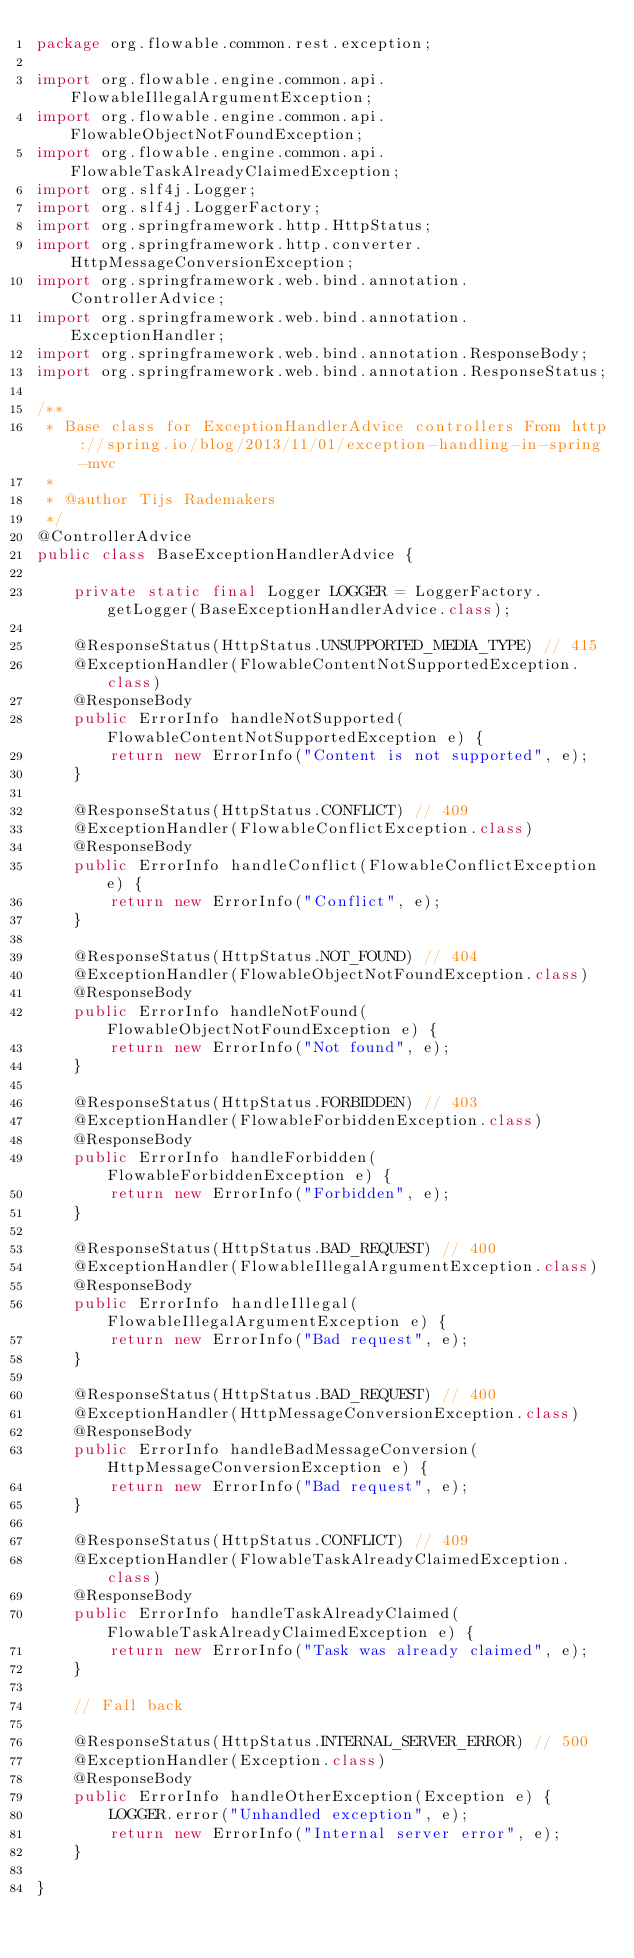<code> <loc_0><loc_0><loc_500><loc_500><_Java_>package org.flowable.common.rest.exception;

import org.flowable.engine.common.api.FlowableIllegalArgumentException;
import org.flowable.engine.common.api.FlowableObjectNotFoundException;
import org.flowable.engine.common.api.FlowableTaskAlreadyClaimedException;
import org.slf4j.Logger;
import org.slf4j.LoggerFactory;
import org.springframework.http.HttpStatus;
import org.springframework.http.converter.HttpMessageConversionException;
import org.springframework.web.bind.annotation.ControllerAdvice;
import org.springframework.web.bind.annotation.ExceptionHandler;
import org.springframework.web.bind.annotation.ResponseBody;
import org.springframework.web.bind.annotation.ResponseStatus;

/**
 * Base class for ExceptionHandlerAdvice controllers From http://spring.io/blog/2013/11/01/exception-handling-in-spring-mvc
 * 
 * @author Tijs Rademakers
 */
@ControllerAdvice
public class BaseExceptionHandlerAdvice {

    private static final Logger LOGGER = LoggerFactory.getLogger(BaseExceptionHandlerAdvice.class);

    @ResponseStatus(HttpStatus.UNSUPPORTED_MEDIA_TYPE) // 415
    @ExceptionHandler(FlowableContentNotSupportedException.class)
    @ResponseBody
    public ErrorInfo handleNotSupported(FlowableContentNotSupportedException e) {
        return new ErrorInfo("Content is not supported", e);
    }

    @ResponseStatus(HttpStatus.CONFLICT) // 409
    @ExceptionHandler(FlowableConflictException.class)
    @ResponseBody
    public ErrorInfo handleConflict(FlowableConflictException e) {
        return new ErrorInfo("Conflict", e);
    }

    @ResponseStatus(HttpStatus.NOT_FOUND) // 404
    @ExceptionHandler(FlowableObjectNotFoundException.class)
    @ResponseBody
    public ErrorInfo handleNotFound(FlowableObjectNotFoundException e) {
        return new ErrorInfo("Not found", e);
    }

    @ResponseStatus(HttpStatus.FORBIDDEN) // 403
    @ExceptionHandler(FlowableForbiddenException.class)
    @ResponseBody
    public ErrorInfo handleForbidden(FlowableForbiddenException e) {
        return new ErrorInfo("Forbidden", e);
    }

    @ResponseStatus(HttpStatus.BAD_REQUEST) // 400
    @ExceptionHandler(FlowableIllegalArgumentException.class)
    @ResponseBody
    public ErrorInfo handleIllegal(FlowableIllegalArgumentException e) {
        return new ErrorInfo("Bad request", e);
    }

    @ResponseStatus(HttpStatus.BAD_REQUEST) // 400
    @ExceptionHandler(HttpMessageConversionException.class)
    @ResponseBody
    public ErrorInfo handleBadMessageConversion(HttpMessageConversionException e) {
        return new ErrorInfo("Bad request", e);
    }

    @ResponseStatus(HttpStatus.CONFLICT) // 409
    @ExceptionHandler(FlowableTaskAlreadyClaimedException.class)
    @ResponseBody
    public ErrorInfo handleTaskAlreadyClaimed(FlowableTaskAlreadyClaimedException e) {
        return new ErrorInfo("Task was already claimed", e);
    }

    // Fall back

    @ResponseStatus(HttpStatus.INTERNAL_SERVER_ERROR) // 500
    @ExceptionHandler(Exception.class)
    @ResponseBody
    public ErrorInfo handleOtherException(Exception e) {
        LOGGER.error("Unhandled exception", e);
        return new ErrorInfo("Internal server error", e);
    }

}
</code> 